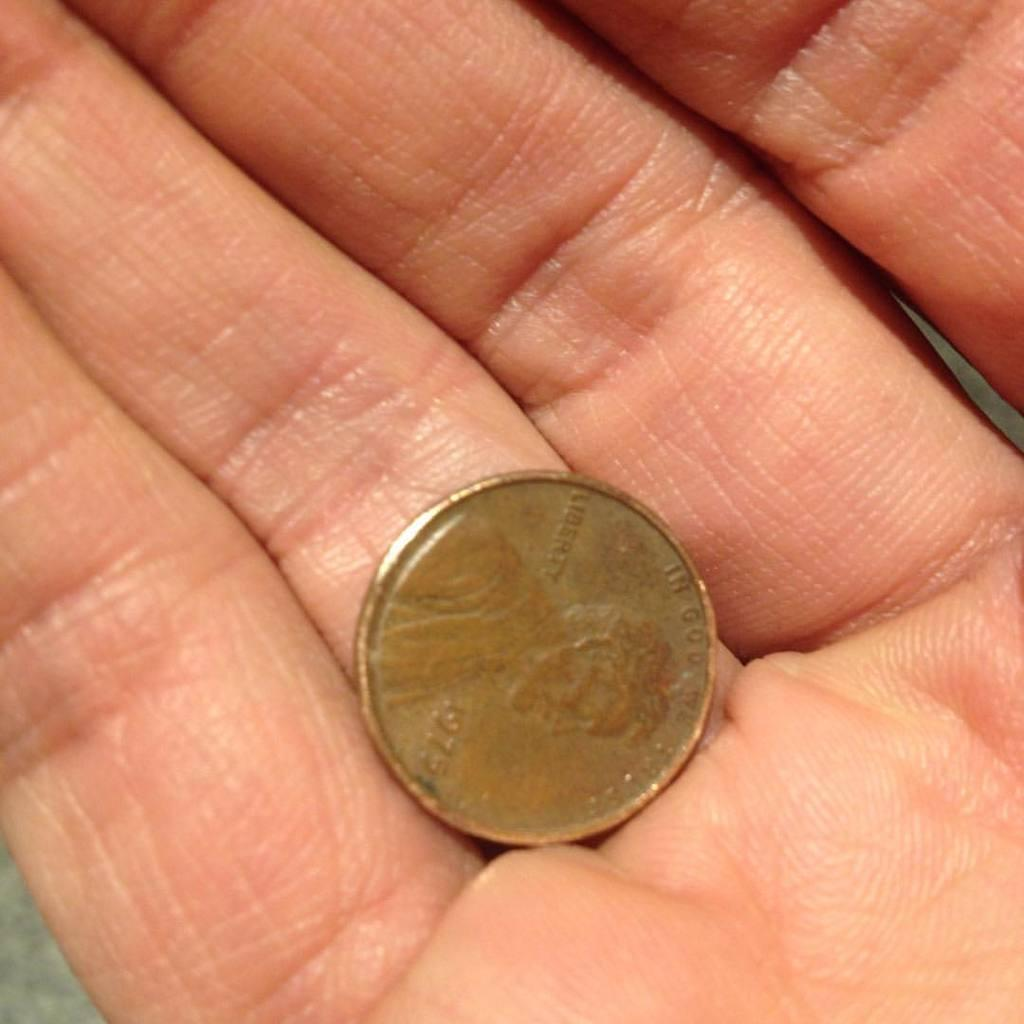<image>
Provide a brief description of the given image. A person holds a coin from 1975 in their hand. 